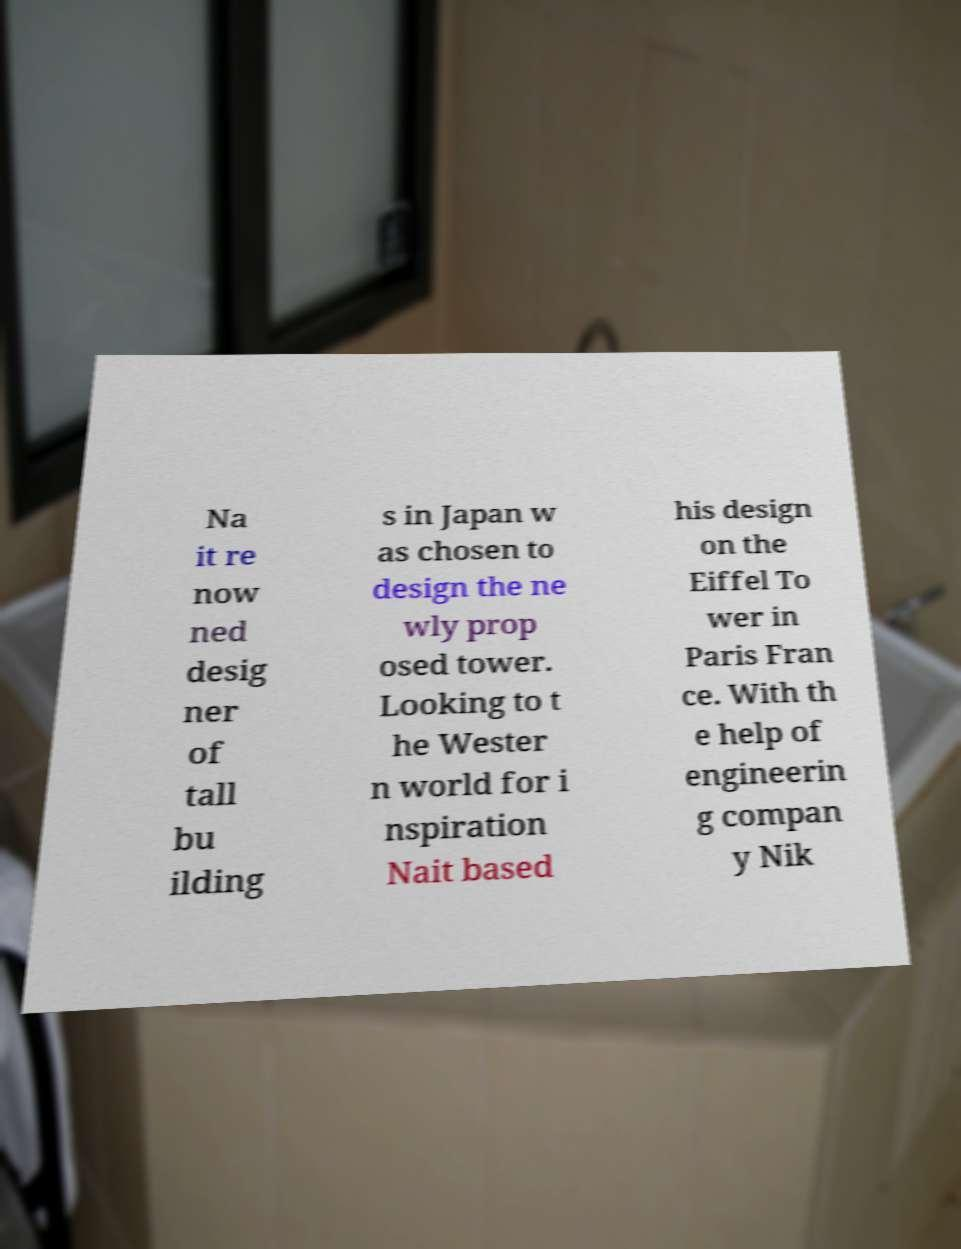Please identify and transcribe the text found in this image. Na it re now ned desig ner of tall bu ilding s in Japan w as chosen to design the ne wly prop osed tower. Looking to t he Wester n world for i nspiration Nait based his design on the Eiffel To wer in Paris Fran ce. With th e help of engineerin g compan y Nik 